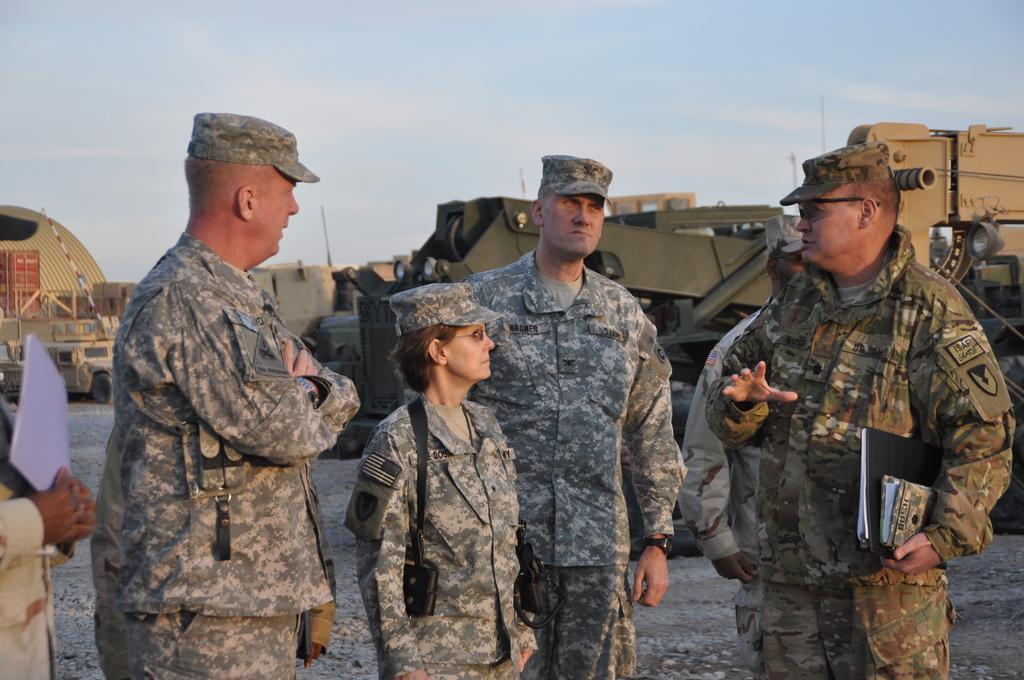Describe this image in one or two sentences. In the image there are three military men and a woman standing in the front, behind them there are army tanks and trucks all over the place, the land is of marshy rocks and above its sky. 